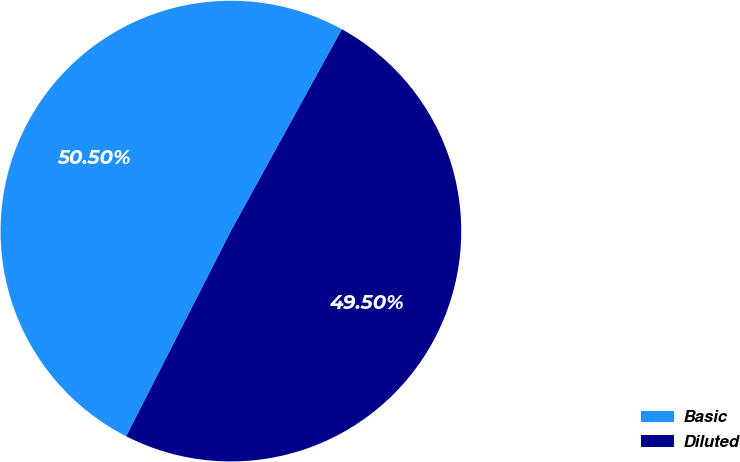<chart> <loc_0><loc_0><loc_500><loc_500><pie_chart><fcel>Basic<fcel>Diluted<nl><fcel>50.5%<fcel>49.5%<nl></chart> 